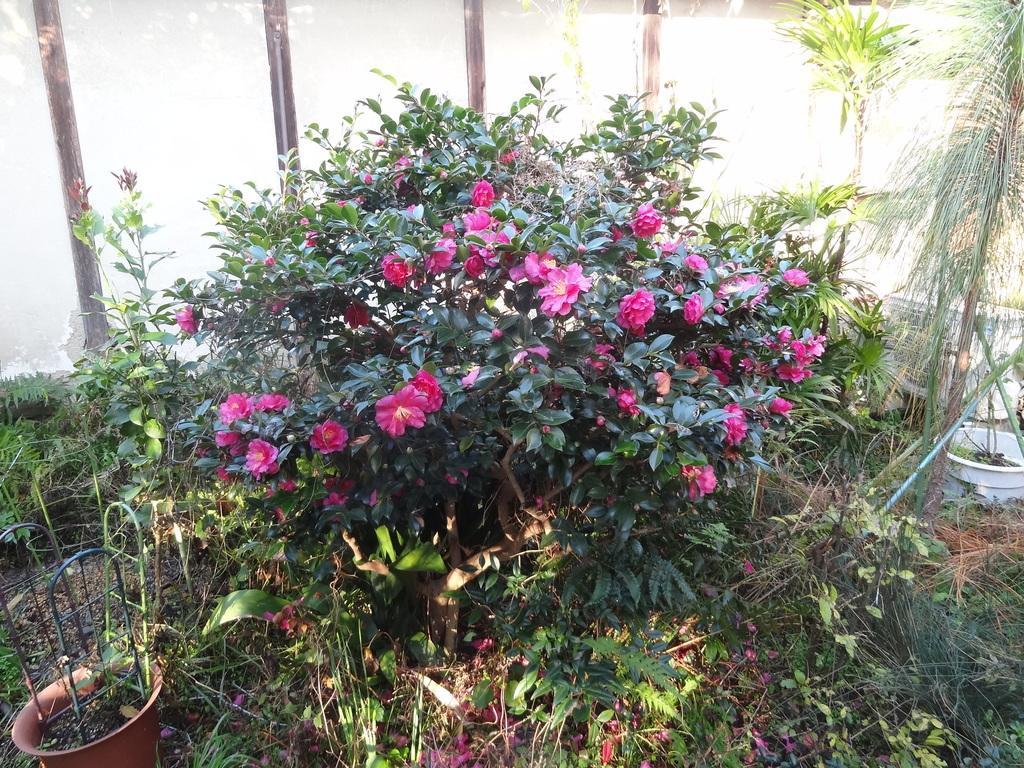How would you summarize this image in a sentence or two? In the center of the image we can see a plant with flowers. To the left side, we can see a container with metal frames. In the background, we can see group of plants and a wall. 